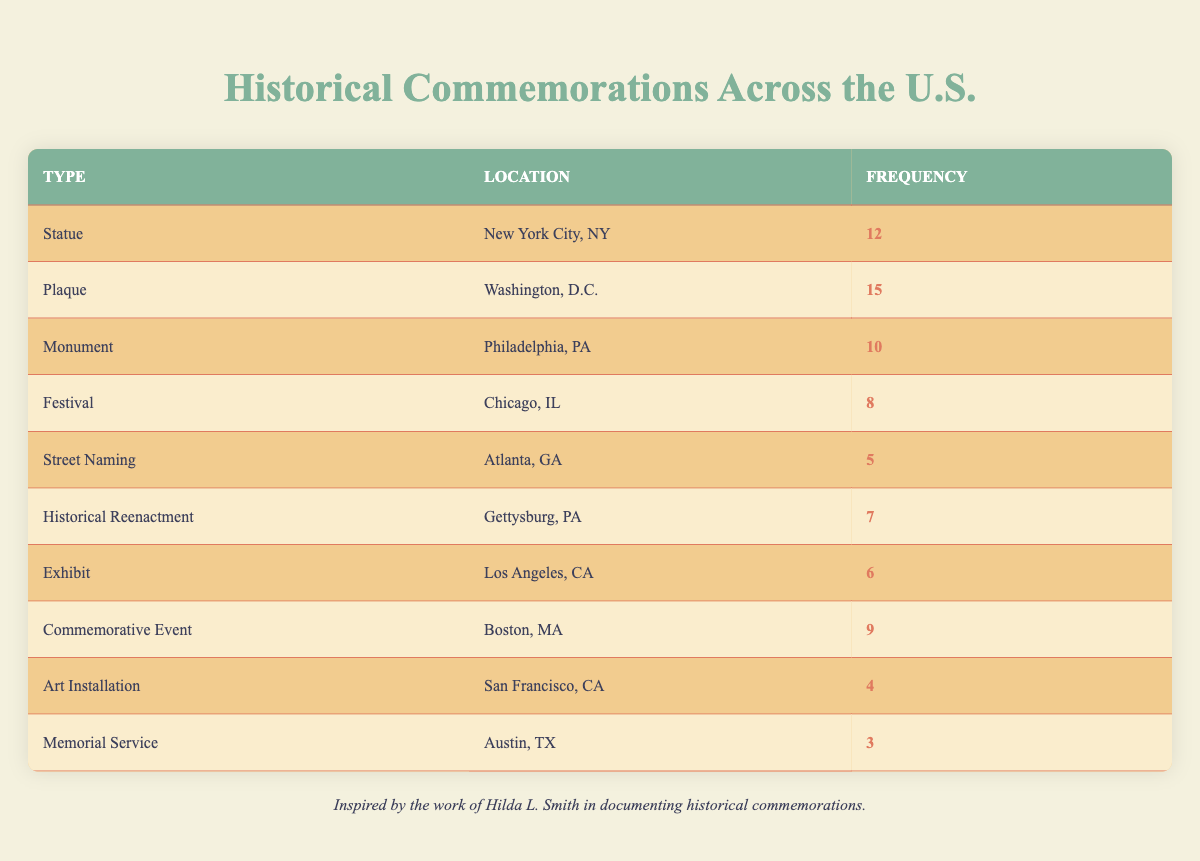What is the frequency of plaques in Washington, D.C.? The table lists the commemorations along with their corresponding locations and frequencies. For Washington, D.C., the type of commemoration is "Plaque," and its frequency is given as 15.
Answer: 15 Which location has the highest number of commemorations? By examining the frequency column, the highest value is in Washington, D.C. with 15 commemorations (Plaque). Other entries are less than this value, making it the highest.
Answer: Washington, D.C What is the total frequency of all commemorations listed? To find the total frequency, we must sum the frequencies of all the types of commemorations: 12 + 15 + 10 + 8 + 5 + 7 + 6 + 9 + 4 + 3 = 79. Thus, the total is 79.
Answer: 79 How many more statues are there than memorial services? The frequency of statues is 12, and for memorial services, it is 3. By subtracting the frequency of memorial services from that of statues: 12 - 3 = 9.
Answer: 9 Is there more than one type of commemoration with a frequency greater than 10? From the table, we see that only one type, "Plaque" in Washington, D.C. has a frequency of 15. Thus, there is not more than one type exceeding 10.
Answer: No Which location has a commemorative type that is a festival, and what is its frequency? The table shows that Chicago, IL has a commemorative type categorized as "Festival," and its frequency is listed as 8.
Answer: Chicago, IL; 8 What is the average frequency of commemorations across all locations? The total frequency is 79 (from the previous answer) and the number of commemoration types is 10. To find the average: 79 / 10 = 7.9.
Answer: 7.9 Which type of commemoration is represented by the lowest frequency and what is that frequency? From the table, "Art Installation" in San Francisco, CA has the lowest frequency listed at 4.
Answer: Art Installation; 4 Do any locations host both a historical reenactment and a statue? By checking the table, historical reenactments take place in Gettysburg, PA and statues are in New York City, NY. Both commemorations do not appear in the same location, hence the answer is no.
Answer: No 